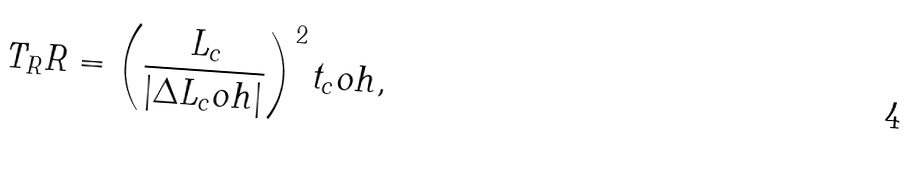Convert formula to latex. <formula><loc_0><loc_0><loc_500><loc_500>T _ { R } R = \left ( \frac { L _ { c } } { | \Delta L _ { c } o h | } \right ) ^ { 2 } t _ { c } o h ,</formula> 